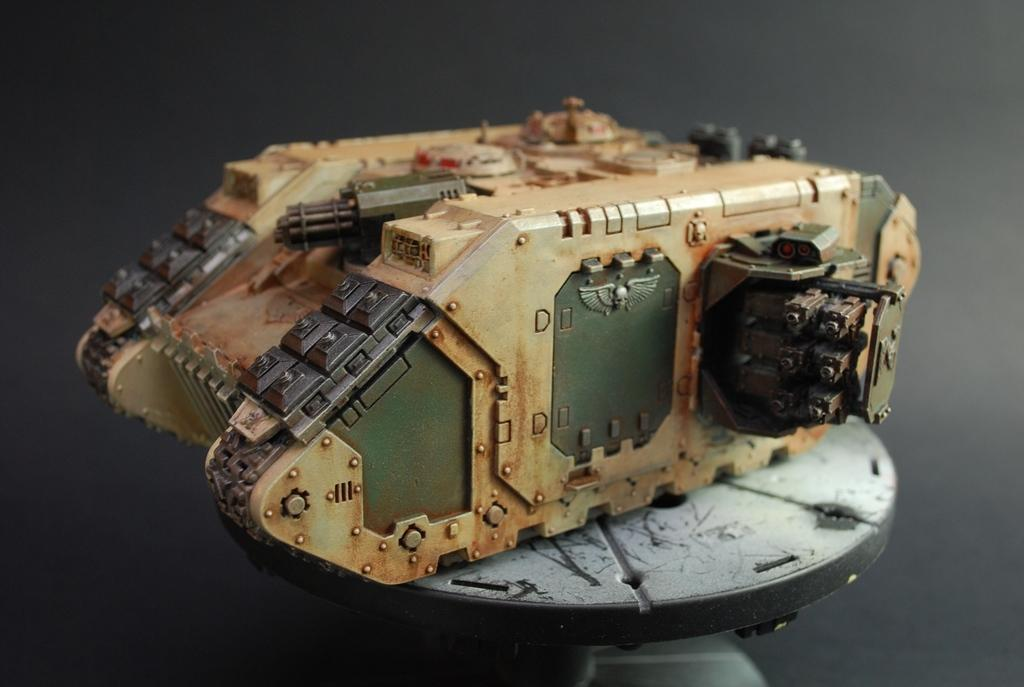What type of toy is in the image? There is a toy panzer in the image. Where is the toy panzer located? The toy panzer is on a surface. What can be seen at the bottom of the image? There is an object at the bottom of the image. How would you describe the overall lighting in the image? The background of the image is dark. Can you see any dinosaurs wearing a crown in the image? There are no dinosaurs or crowns present in the image; it features a toy panzer on a surface. What type of rat is visible in the image? There is no rat present in the image. 